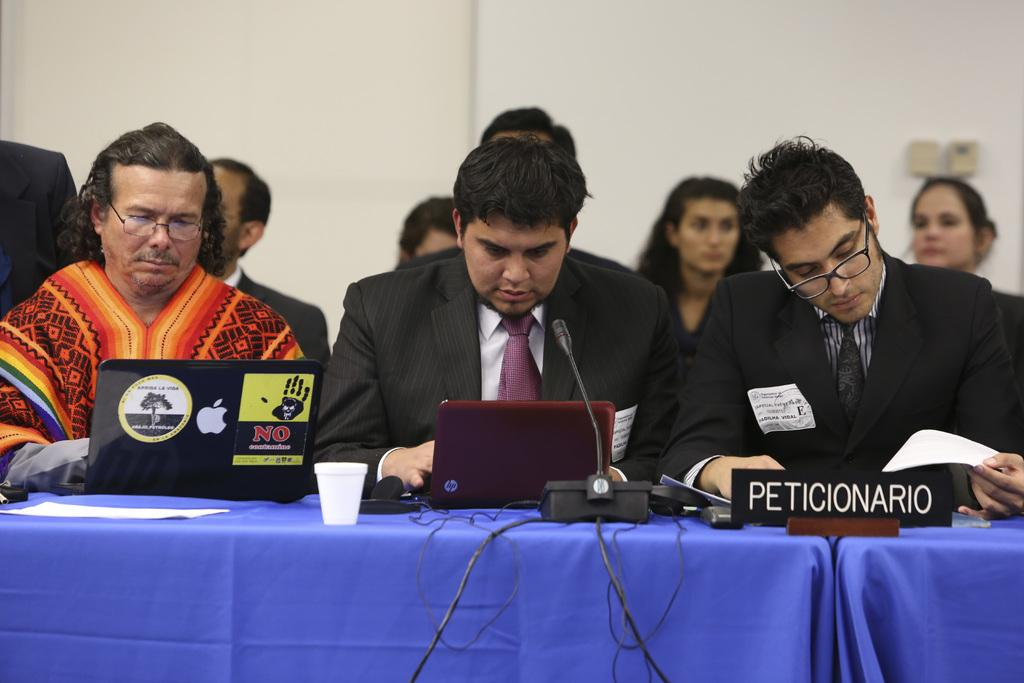What are the people in the image doing? The people in the image are sitting. What is in front of the people who are sitting? They have a table in front of them. Can you describe the people sitting in the backdrop? There are two women sitting in the backdrop. What can be seen behind the people and the table? There is a wall visible in the image. How many rabbits can be seen hopping around the table in the image? There are no rabbits present in the image; it only features people sitting and a table. 